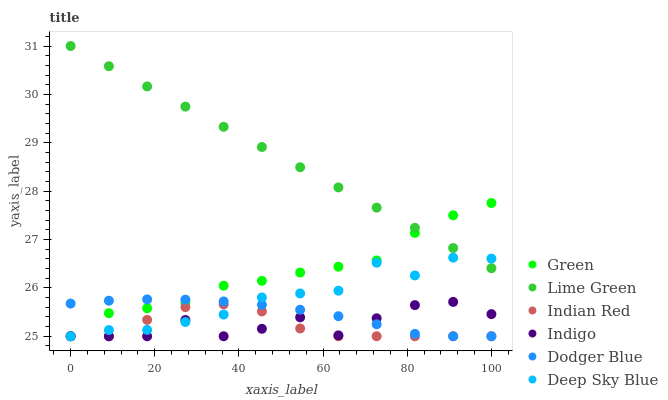Does Indian Red have the minimum area under the curve?
Answer yes or no. Yes. Does Lime Green have the maximum area under the curve?
Answer yes or no. Yes. Does Green have the minimum area under the curve?
Answer yes or no. No. Does Green have the maximum area under the curve?
Answer yes or no. No. Is Lime Green the smoothest?
Answer yes or no. Yes. Is Indigo the roughest?
Answer yes or no. Yes. Is Indian Red the smoothest?
Answer yes or no. No. Is Indian Red the roughest?
Answer yes or no. No. Does Indigo have the lowest value?
Answer yes or no. Yes. Does Lime Green have the lowest value?
Answer yes or no. No. Does Lime Green have the highest value?
Answer yes or no. Yes. Does Green have the highest value?
Answer yes or no. No. Is Dodger Blue less than Lime Green?
Answer yes or no. Yes. Is Lime Green greater than Indian Red?
Answer yes or no. Yes. Does Indigo intersect Indian Red?
Answer yes or no. Yes. Is Indigo less than Indian Red?
Answer yes or no. No. Is Indigo greater than Indian Red?
Answer yes or no. No. Does Dodger Blue intersect Lime Green?
Answer yes or no. No. 